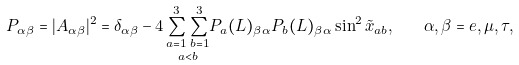<formula> <loc_0><loc_0><loc_500><loc_500>P _ { \alpha \beta } = | A _ { \alpha \beta } | ^ { 2 } = \delta _ { \alpha \beta } - 4 \, \underset { a < b } { \sum _ { a = 1 } ^ { 3 } \sum _ { b = 1 } ^ { 3 } } P _ { a } ( L ) _ { \beta \alpha } P _ { b } ( L ) _ { \beta \alpha } \sin ^ { 2 } \tilde { x } _ { a b } , \quad \alpha , \beta = e , \mu , \tau ,</formula> 